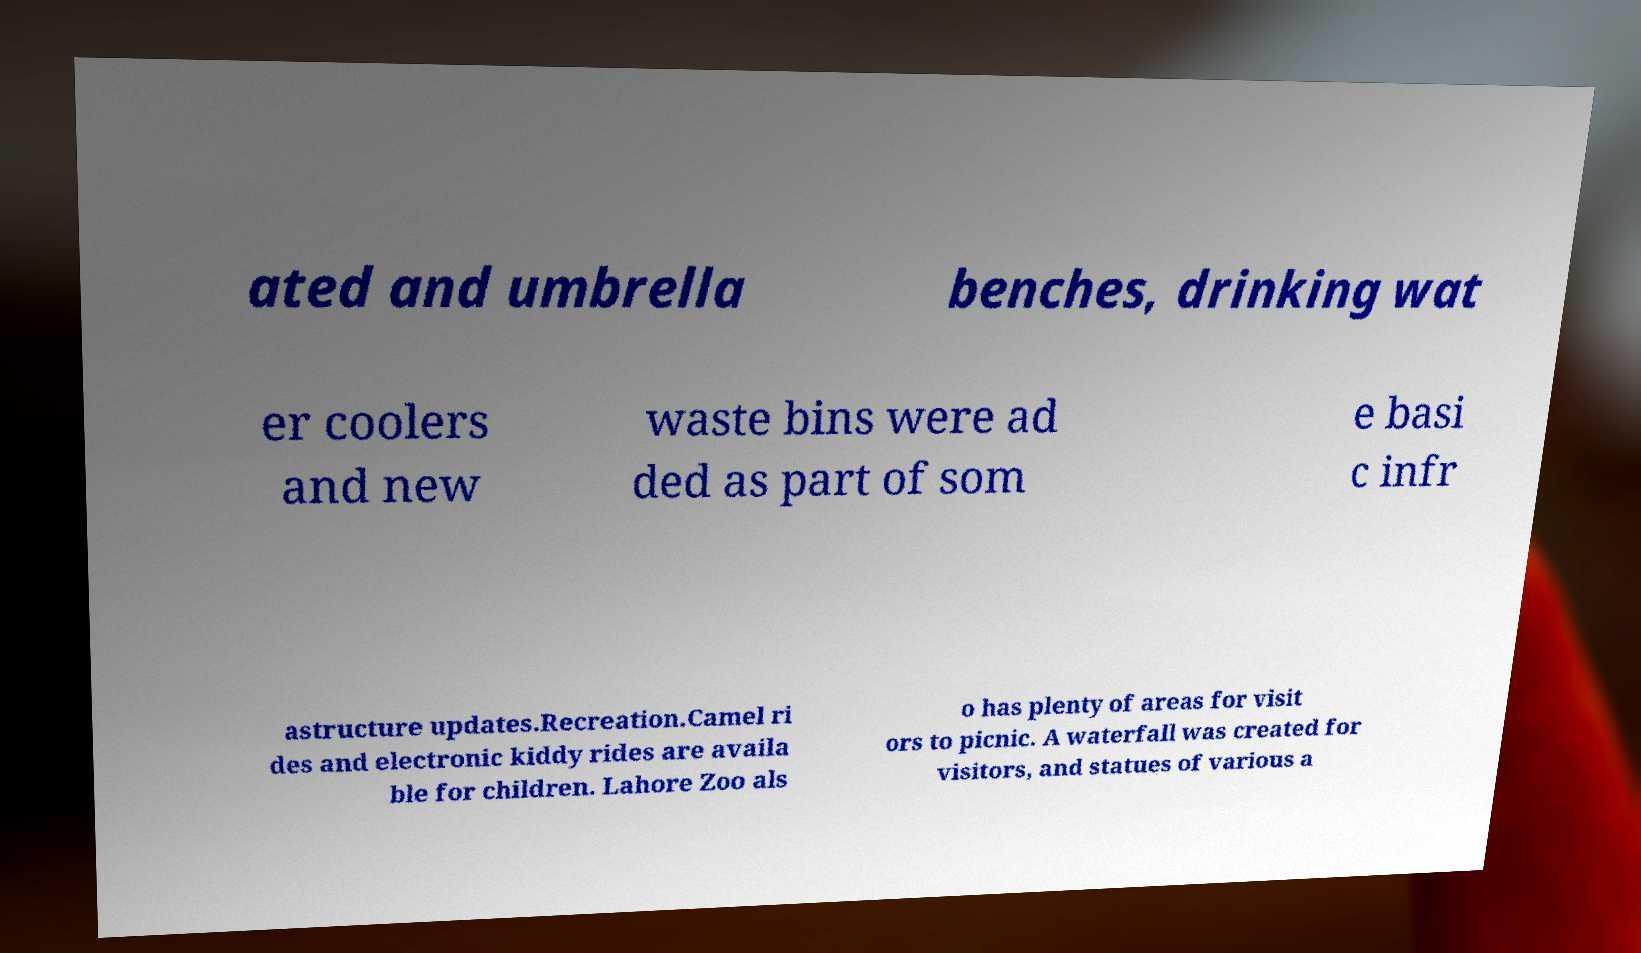Please read and relay the text visible in this image. What does it say? ated and umbrella benches, drinking wat er coolers and new waste bins were ad ded as part of som e basi c infr astructure updates.Recreation.Camel ri des and electronic kiddy rides are availa ble for children. Lahore Zoo als o has plenty of areas for visit ors to picnic. A waterfall was created for visitors, and statues of various a 